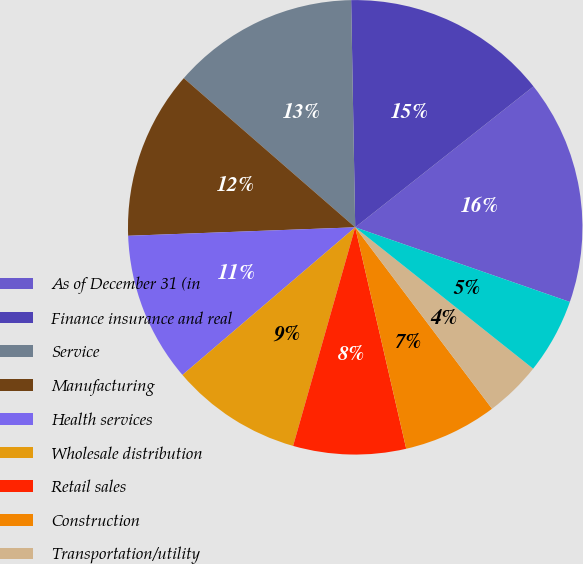Convert chart to OTSL. <chart><loc_0><loc_0><loc_500><loc_500><pie_chart><fcel>As of December 31 (in<fcel>Finance insurance and real<fcel>Service<fcel>Manufacturing<fcel>Health services<fcel>Wholesale distribution<fcel>Retail sales<fcel>Construction<fcel>Transportation/utility<fcel>Arts/entertainment/recreation<nl><fcel>15.97%<fcel>14.64%<fcel>13.32%<fcel>11.99%<fcel>10.66%<fcel>9.34%<fcel>8.01%<fcel>6.68%<fcel>4.03%<fcel>5.36%<nl></chart> 